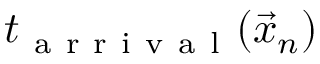Convert formula to latex. <formula><loc_0><loc_0><loc_500><loc_500>t _ { a r r i v a l } ( \vec { x } _ { n } )</formula> 